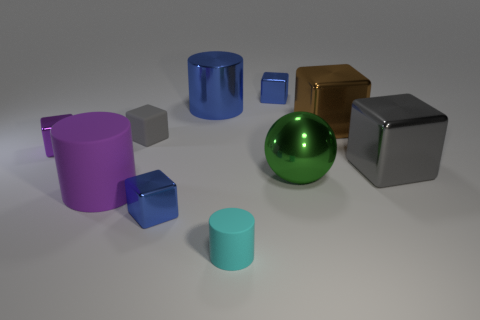What number of gray shiny things have the same shape as the green object?
Your response must be concise. 0. What is the shape of the brown thing that is the same material as the small purple block?
Keep it short and to the point. Cube. There is a large metal thing that is to the left of the blue metal thing that is to the right of the tiny cyan matte thing; what color is it?
Your answer should be compact. Blue. What material is the gray block that is to the right of the tiny blue shiny block in front of the big gray metallic object?
Provide a succinct answer. Metal. What is the material of the other big thing that is the same shape as the large gray object?
Make the answer very short. Metal. Is there a large ball behind the tiny rubber object that is to the left of the blue metallic cube that is in front of the metallic sphere?
Your answer should be very brief. No. What number of other objects are there of the same color as the large metallic ball?
Your response must be concise. 0. What number of big metal things are both on the left side of the green shiny object and in front of the blue cylinder?
Provide a succinct answer. 0. There is a green shiny thing; what shape is it?
Your answer should be very brief. Sphere. How many other things are there of the same material as the tiny purple thing?
Your answer should be compact. 6. 